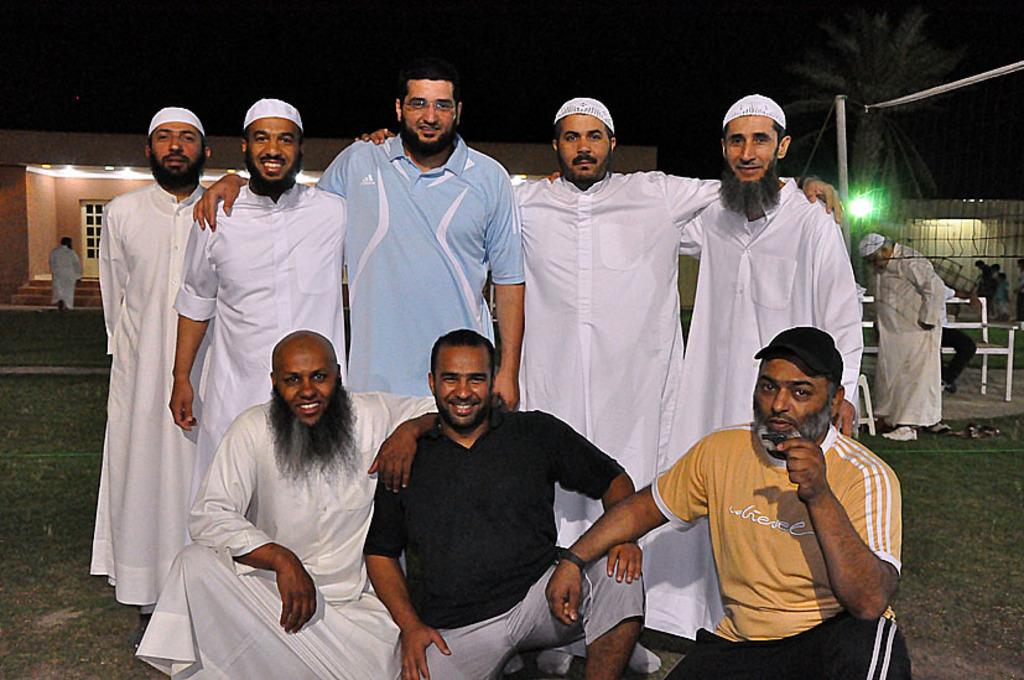What are the people in the image doing? There are people standing and sitting in the image. What can be seen in the background of the image? There is a tree, buildings, a bench, people, lights, and the sky visible in the background. What type of stone is being used to build the shop in the image? There is no shop present in the image, so it is not possible to determine what type of stone is being used. 